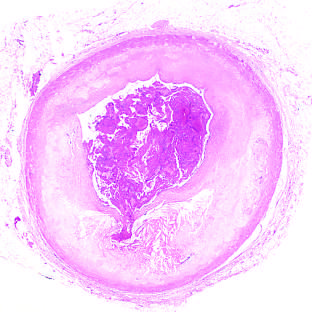s moderate-power view of the plaque superimposed on an atherosclerotic plaque with focal disruption of the fibrous cap, triggering fatal myocardial infarction?
Answer the question using a single word or phrase. No 